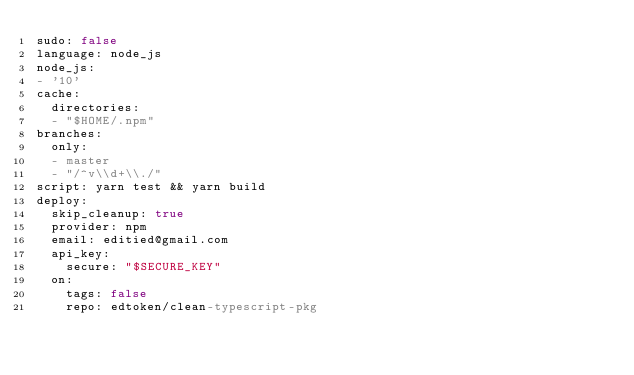Convert code to text. <code><loc_0><loc_0><loc_500><loc_500><_YAML_>sudo: false
language: node_js
node_js:
- '10'
cache:
  directories:
  - "$HOME/.npm"
branches:
  only:
  - master
  - "/^v\\d+\\./"
script: yarn test && yarn build
deploy:
  skip_cleanup: true
  provider: npm
  email: editied@gmail.com
  api_key:
    secure: "$SECURE_KEY"
  on:
    tags: false
    repo: edtoken/clean-typescript-pkg
</code> 